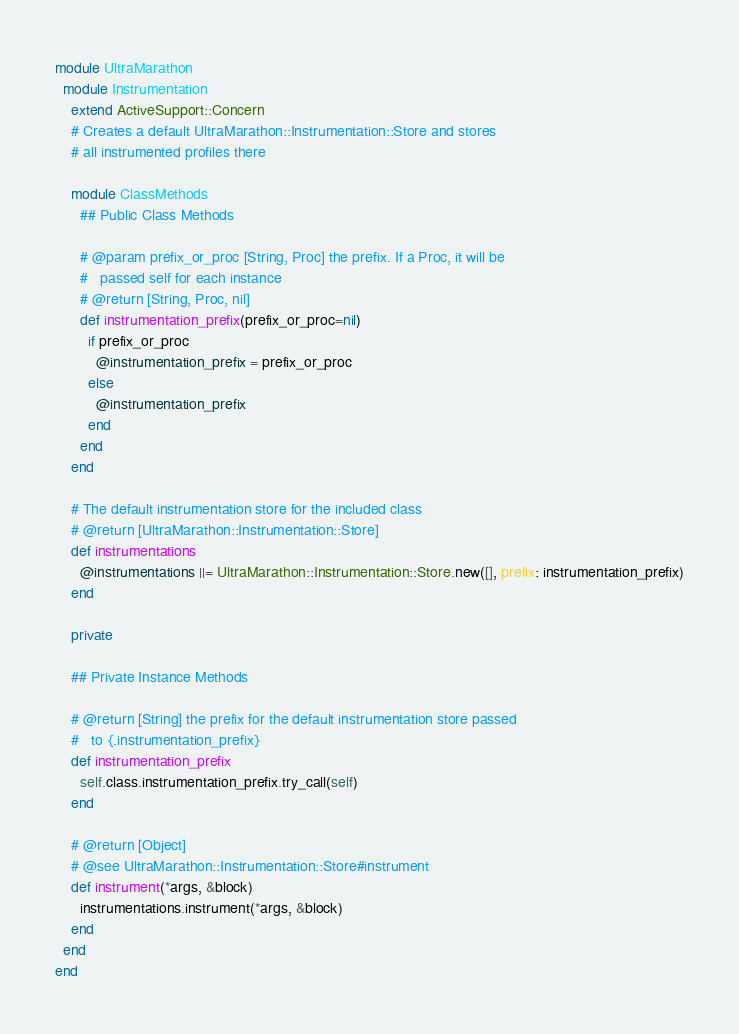<code> <loc_0><loc_0><loc_500><loc_500><_Ruby_>
module UltraMarathon
  module Instrumentation
    extend ActiveSupport::Concern
    # Creates a default UltraMarathon::Instrumentation::Store and stores
    # all instrumented profiles there

    module ClassMethods
      ## Public Class Methods

      # @param prefix_or_proc [String, Proc] the prefix. If a Proc, it will be
      #   passed self for each instance
      # @return [String, Proc, nil]
      def instrumentation_prefix(prefix_or_proc=nil)
        if prefix_or_proc
          @instrumentation_prefix = prefix_or_proc
        else
          @instrumentation_prefix
        end
      end
    end

    # The default instrumentation store for the included class
    # @return [UltraMarathon::Instrumentation::Store]
    def instrumentations
      @instrumentations ||= UltraMarathon::Instrumentation::Store.new([], prefix: instrumentation_prefix)
    end

    private

    ## Private Instance Methods

    # @return [String] the prefix for the default instrumentation store passed
    #   to {.instrumentation_prefix}
    def instrumentation_prefix
      self.class.instrumentation_prefix.try_call(self)
    end

    # @return [Object]
    # @see UltraMarathon::Instrumentation::Store#instrument
    def instrument(*args, &block)
      instrumentations.instrument(*args, &block)
    end
  end
end
</code> 